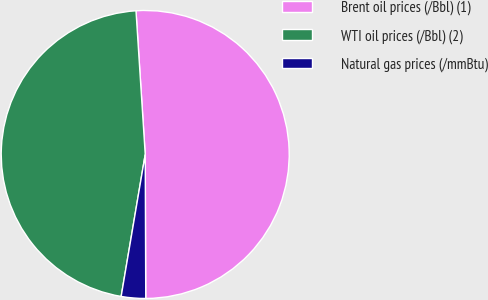Convert chart to OTSL. <chart><loc_0><loc_0><loc_500><loc_500><pie_chart><fcel>Brent oil prices (/Bbl) (1)<fcel>WTI oil prices (/Bbl) (2)<fcel>Natural gas prices (/mmBtu)<nl><fcel>50.97%<fcel>46.31%<fcel>2.73%<nl></chart> 